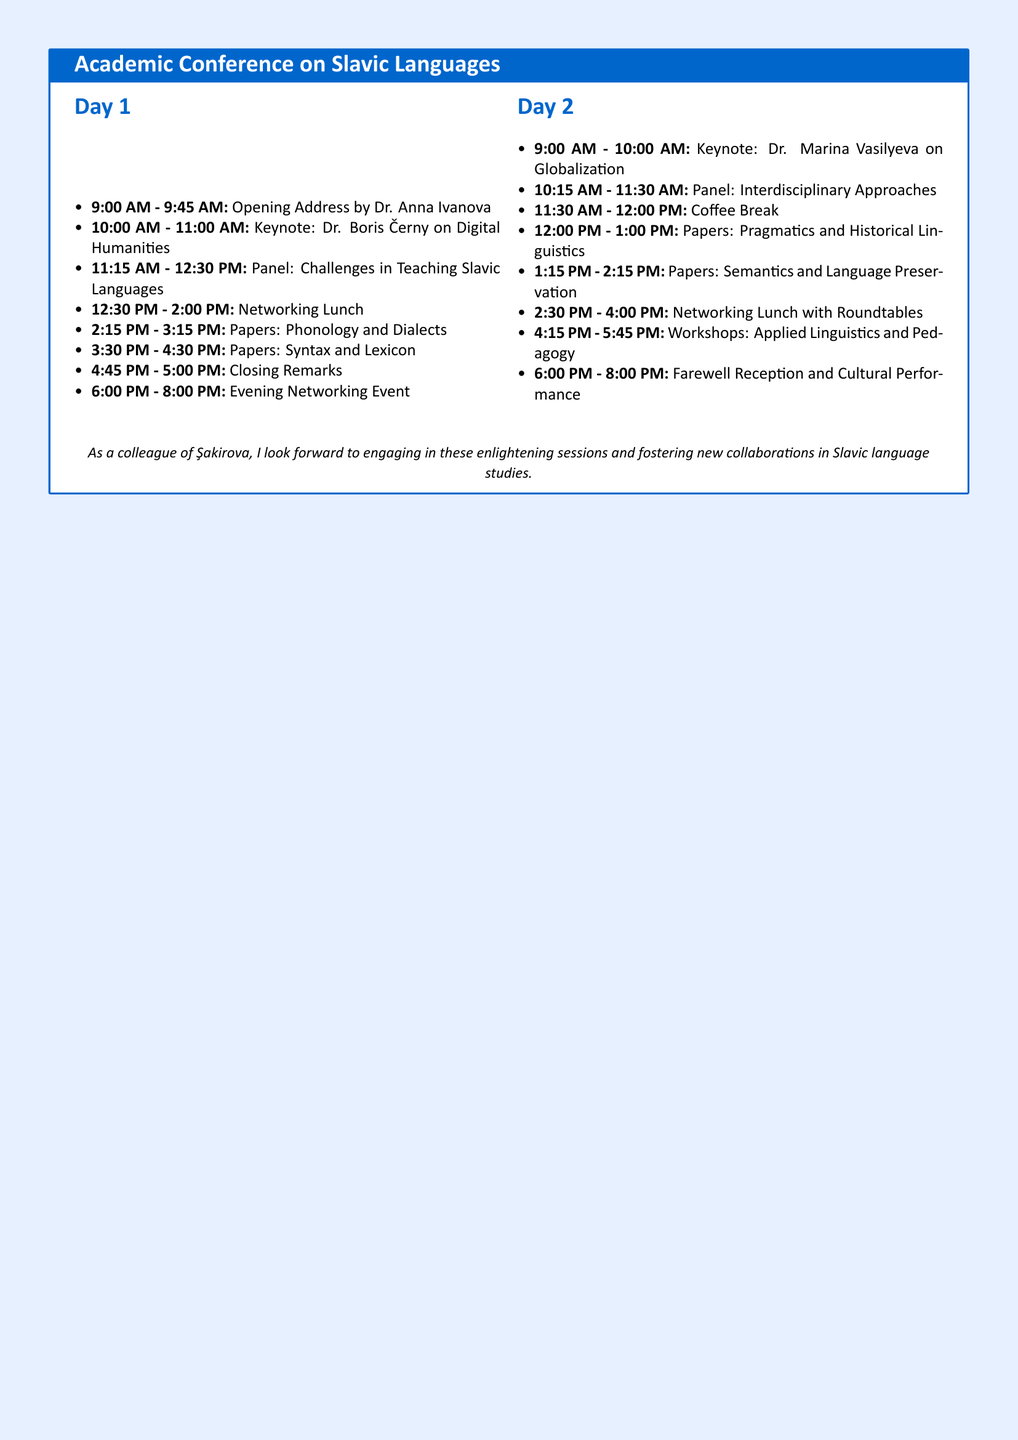what time does the conference start on Day 1? The conference starts at 9:00 AM on Day 1, as indicated in the itinerary.
Answer: 9:00 AM who is the keynote speaker on Day 2? The keynote speaker on Day 2 is Dr. Marina Vasilyeva, mentioned in the document.
Answer: Dr. Marina Vasilyeva how long is the networking lunch on Day 1? The networking lunch on Day 1 is scheduled for 1 hour and 30 minutes, from 12:30 PM to 2:00 PM.
Answer: 1 hour and 30 minutes what is the topic of Dr. Boris Černy's keynote address? The topic of Dr. Boris Černy's keynote address is "Digital Humanities," as stated in the schedule.
Answer: Digital Humanities how many workshops are scheduled on Day 2? There is one workshop scheduled on Day 2, listed under the Workshops section.
Answer: One what event follows the closing remarks on Day 1? The event that follows the closing remarks on Day 1 is an "Evening Networking Event."
Answer: Evening Networking Event how are the networking events structured on Day 2? The networking lunch on Day 2 includes roundtables, as per the itinerary details.
Answer: Roundtables what is the duration of the coffee break? The coffee break lasts for 30 minutes, from 11:30 AM to 12:00 PM.
Answer: 30 minutes what type of cultural activity is planned for the farewell reception? The farewell reception includes a cultural performance, as specified in the document.
Answer: Cultural Performance 